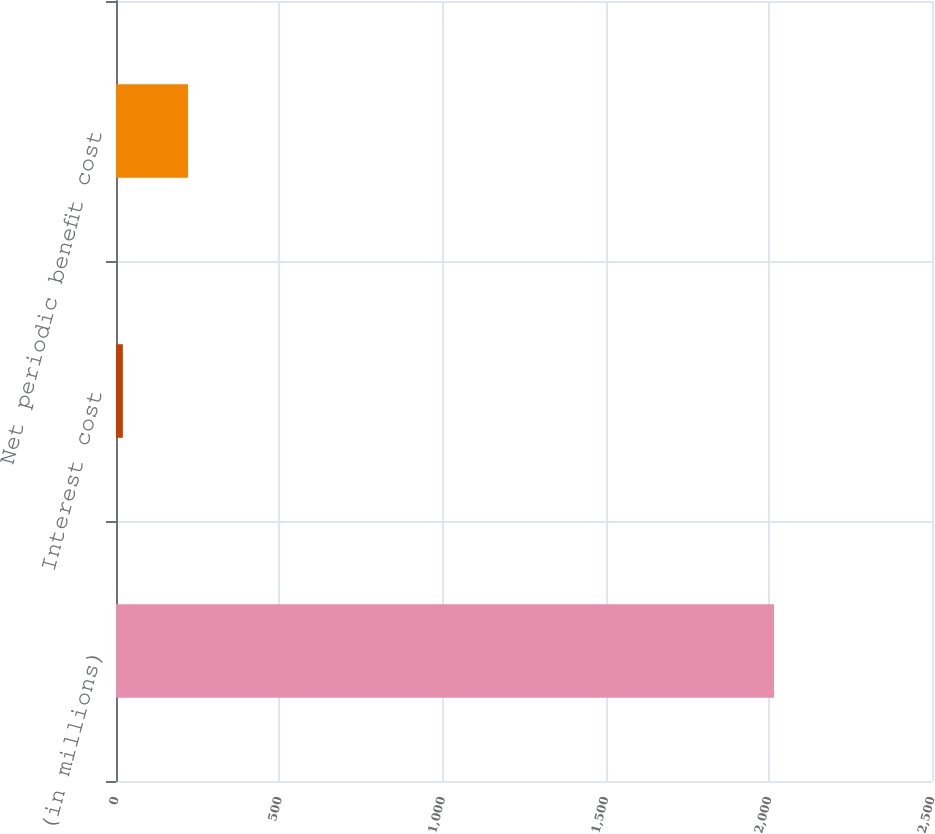<chart> <loc_0><loc_0><loc_500><loc_500><bar_chart><fcel>(in millions)<fcel>Interest cost<fcel>Net periodic benefit cost<nl><fcel>2016<fcel>21<fcel>220.5<nl></chart> 